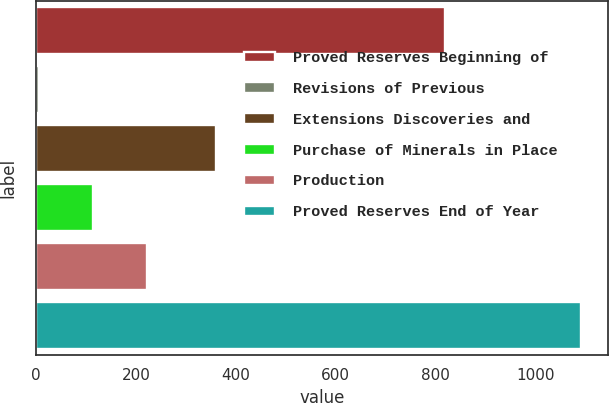Convert chart to OTSL. <chart><loc_0><loc_0><loc_500><loc_500><bar_chart><fcel>Proved Reserves Beginning of<fcel>Revisions of Previous<fcel>Extensions Discoveries and<fcel>Purchase of Minerals in Place<fcel>Production<fcel>Proved Reserves End of Year<nl><fcel>820<fcel>5<fcel>360<fcel>113.7<fcel>222.4<fcel>1092<nl></chart> 